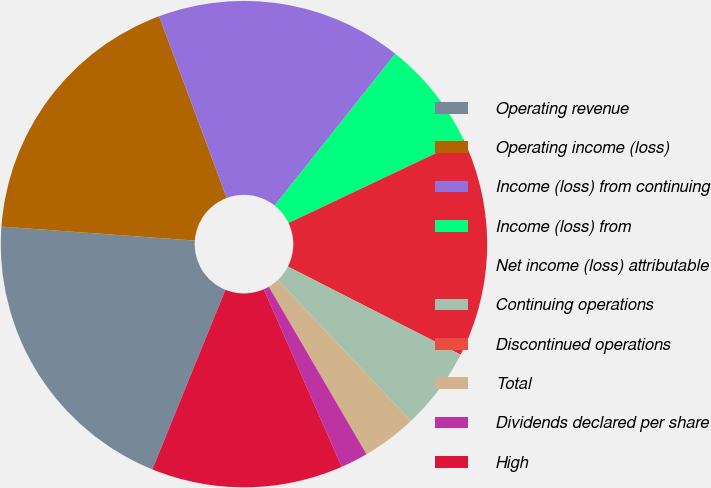Convert chart. <chart><loc_0><loc_0><loc_500><loc_500><pie_chart><fcel>Operating revenue<fcel>Operating income (loss)<fcel>Income (loss) from continuing<fcel>Income (loss) from<fcel>Net income (loss) attributable<fcel>Continuing operations<fcel>Discontinued operations<fcel>Total<fcel>Dividends declared per share<fcel>High<nl><fcel>20.0%<fcel>18.18%<fcel>16.36%<fcel>7.27%<fcel>14.55%<fcel>5.45%<fcel>0.0%<fcel>3.64%<fcel>1.82%<fcel>12.73%<nl></chart> 